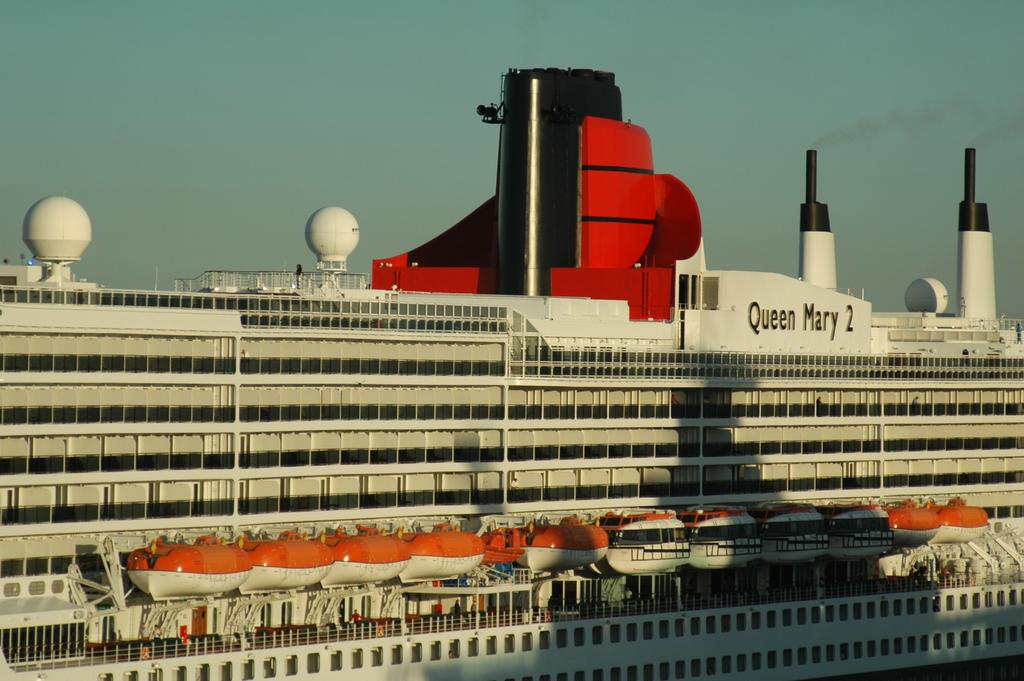What is the main subject of the image? The main subject of the image is a ship. What colors can be seen on the ship? The ship has white, red, and black colors. What type of leather material is covering the jar in the image? There is no jar or leather material present in the image; it features a ship with white, red, and black colors. 